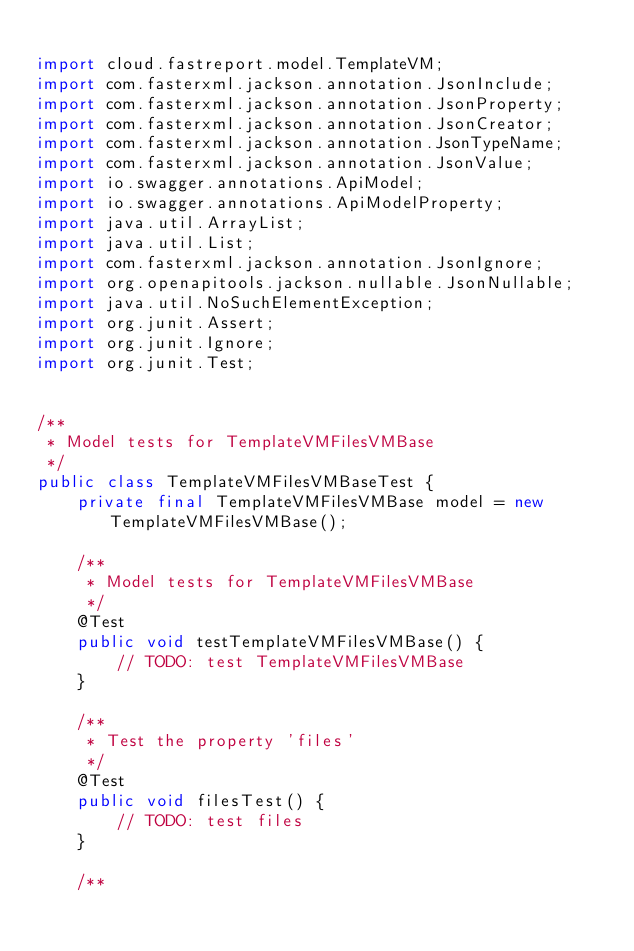<code> <loc_0><loc_0><loc_500><loc_500><_Java_>
import cloud.fastreport.model.TemplateVM;
import com.fasterxml.jackson.annotation.JsonInclude;
import com.fasterxml.jackson.annotation.JsonProperty;
import com.fasterxml.jackson.annotation.JsonCreator;
import com.fasterxml.jackson.annotation.JsonTypeName;
import com.fasterxml.jackson.annotation.JsonValue;
import io.swagger.annotations.ApiModel;
import io.swagger.annotations.ApiModelProperty;
import java.util.ArrayList;
import java.util.List;
import com.fasterxml.jackson.annotation.JsonIgnore;
import org.openapitools.jackson.nullable.JsonNullable;
import java.util.NoSuchElementException;
import org.junit.Assert;
import org.junit.Ignore;
import org.junit.Test;


/**
 * Model tests for TemplateVMFilesVMBase
 */
public class TemplateVMFilesVMBaseTest {
    private final TemplateVMFilesVMBase model = new TemplateVMFilesVMBase();

    /**
     * Model tests for TemplateVMFilesVMBase
     */
    @Test
    public void testTemplateVMFilesVMBase() {
        // TODO: test TemplateVMFilesVMBase
    }

    /**
     * Test the property 'files'
     */
    @Test
    public void filesTest() {
        // TODO: test files
    }

    /**</code> 